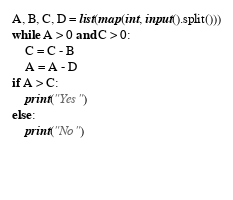Convert code to text. <code><loc_0><loc_0><loc_500><loc_500><_Python_>A, B, C, D = list(map(int, input().split()))
while A > 0 and C > 0:
    C = C - B
    A = A - D
if A > C:
    print("Yes")
else:
    print("No")


    
</code> 